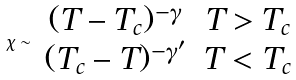Convert formula to latex. <formula><loc_0><loc_0><loc_500><loc_500>\chi \sim \begin{array} { c c } ( T - T _ { c } ) ^ { - \gamma } & T > T _ { c } \\ ( T _ { c } - T ) ^ { - \gamma ^ { \prime } } & T < T _ { c } \end{array}</formula> 